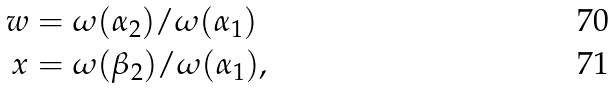<formula> <loc_0><loc_0><loc_500><loc_500>w & = \omega ( \alpha _ { 2 } ) / \omega ( \alpha _ { 1 } ) \\ x & = \omega ( \beta _ { 2 } ) / \omega ( \alpha _ { 1 } ) ,</formula> 